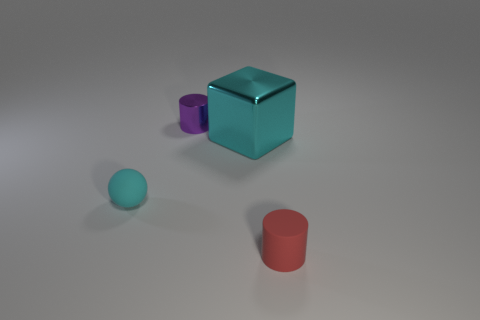Do the big metallic object and the tiny rubber sphere have the same color?
Keep it short and to the point. Yes. There is another thing that is the same color as the large object; what material is it?
Offer a very short reply. Rubber. How many tiny objects are right of the small thing on the left side of the tiny cylinder to the left of the tiny red matte thing?
Make the answer very short. 2. Does the large cyan thing have the same shape as the matte thing right of the cyan sphere?
Make the answer very short. No. Is the number of small rubber things greater than the number of tiny cyan things?
Keep it short and to the point. Yes. Is there anything else that has the same size as the cyan block?
Offer a terse response. No. There is a rubber thing behind the tiny red rubber object; is its shape the same as the tiny red thing?
Provide a short and direct response. No. Is the number of metallic cylinders that are to the right of the purple cylinder greater than the number of small red matte objects?
Your answer should be very brief. No. There is a rubber object that is behind the small thing that is to the right of the large cyan metal thing; what is its color?
Your answer should be compact. Cyan. What number of large cyan metal blocks are there?
Ensure brevity in your answer.  1. 